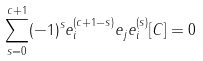Convert formula to latex. <formula><loc_0><loc_0><loc_500><loc_500>\sum _ { s = 0 } ^ { c + 1 } ( - 1 ) ^ { s } e _ { i } ^ { ( c + 1 - s ) } e _ { j } e _ { i } ^ { ( s ) } [ C ] = 0</formula> 